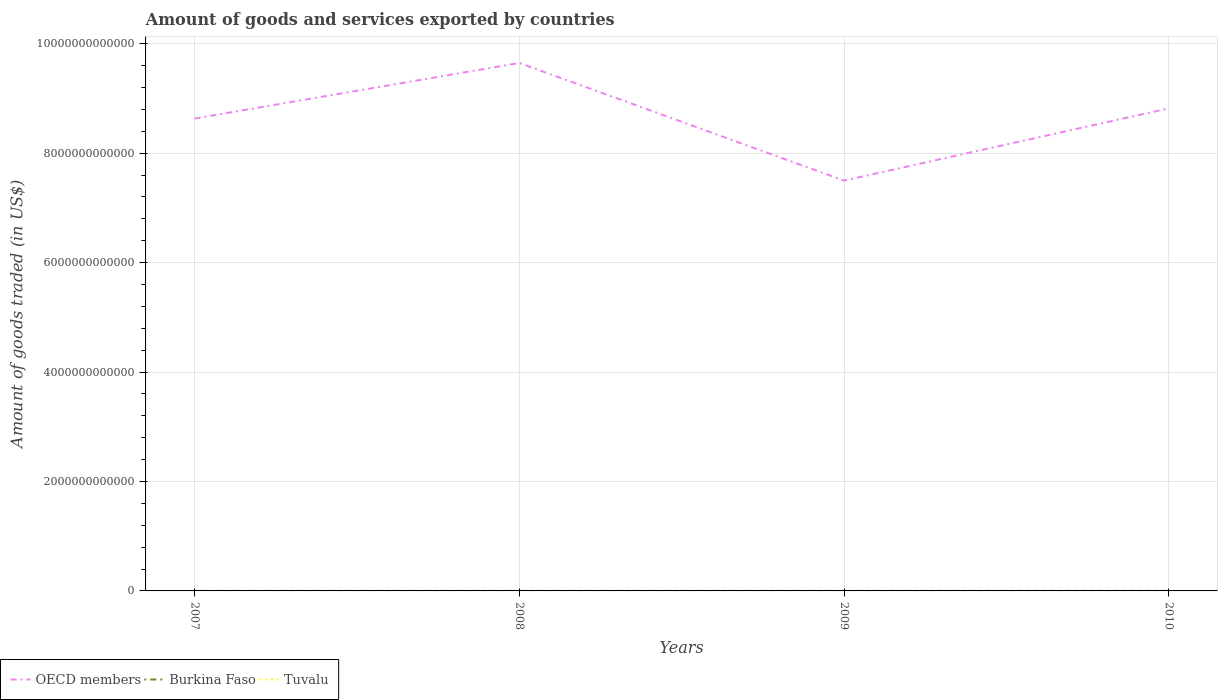How many different coloured lines are there?
Offer a terse response. 3. Does the line corresponding to Tuvalu intersect with the line corresponding to Burkina Faso?
Your answer should be very brief. No. Across all years, what is the maximum total amount of goods and services exported in OECD members?
Your response must be concise. 7.50e+12. What is the total total amount of goods and services exported in Tuvalu in the graph?
Keep it short and to the point. -7.44e+06. What is the difference between the highest and the second highest total amount of goods and services exported in Tuvalu?
Ensure brevity in your answer.  9.61e+06. What is the difference between the highest and the lowest total amount of goods and services exported in OECD members?
Offer a very short reply. 2. Is the total amount of goods and services exported in Tuvalu strictly greater than the total amount of goods and services exported in OECD members over the years?
Make the answer very short. Yes. How many years are there in the graph?
Offer a terse response. 4. What is the difference between two consecutive major ticks on the Y-axis?
Ensure brevity in your answer.  2.00e+12. Does the graph contain any zero values?
Offer a terse response. No. Does the graph contain grids?
Your answer should be compact. Yes. Where does the legend appear in the graph?
Provide a succinct answer. Bottom left. How many legend labels are there?
Keep it short and to the point. 3. What is the title of the graph?
Your answer should be compact. Amount of goods and services exported by countries. Does "Paraguay" appear as one of the legend labels in the graph?
Your answer should be compact. No. What is the label or title of the Y-axis?
Provide a short and direct response. Amount of goods traded (in US$). What is the Amount of goods traded (in US$) in OECD members in 2007?
Make the answer very short. 8.63e+12. What is the Amount of goods traded (in US$) of Burkina Faso in 2007?
Keep it short and to the point. 6.55e+08. What is the Amount of goods traded (in US$) in Tuvalu in 2007?
Offer a very short reply. 4.01e+05. What is the Amount of goods traded (in US$) in OECD members in 2008?
Give a very brief answer. 9.65e+12. What is the Amount of goods traded (in US$) in Burkina Faso in 2008?
Ensure brevity in your answer.  8.58e+08. What is the Amount of goods traded (in US$) of Tuvalu in 2008?
Make the answer very short. 5.43e+05. What is the Amount of goods traded (in US$) in OECD members in 2009?
Your answer should be very brief. 7.50e+12. What is the Amount of goods traded (in US$) of Burkina Faso in 2009?
Ensure brevity in your answer.  9.00e+08. What is the Amount of goods traded (in US$) of Tuvalu in 2009?
Keep it short and to the point. 2.57e+06. What is the Amount of goods traded (in US$) of OECD members in 2010?
Give a very brief answer. 8.82e+12. What is the Amount of goods traded (in US$) in Burkina Faso in 2010?
Give a very brief answer. 1.59e+09. What is the Amount of goods traded (in US$) of Tuvalu in 2010?
Your response must be concise. 1.00e+07. Across all years, what is the maximum Amount of goods traded (in US$) of OECD members?
Give a very brief answer. 9.65e+12. Across all years, what is the maximum Amount of goods traded (in US$) of Burkina Faso?
Make the answer very short. 1.59e+09. Across all years, what is the maximum Amount of goods traded (in US$) of Tuvalu?
Offer a terse response. 1.00e+07. Across all years, what is the minimum Amount of goods traded (in US$) in OECD members?
Offer a terse response. 7.50e+12. Across all years, what is the minimum Amount of goods traded (in US$) of Burkina Faso?
Make the answer very short. 6.55e+08. Across all years, what is the minimum Amount of goods traded (in US$) in Tuvalu?
Provide a short and direct response. 4.01e+05. What is the total Amount of goods traded (in US$) in OECD members in the graph?
Ensure brevity in your answer.  3.46e+13. What is the total Amount of goods traded (in US$) in Burkina Faso in the graph?
Your answer should be compact. 4.00e+09. What is the total Amount of goods traded (in US$) in Tuvalu in the graph?
Offer a terse response. 1.35e+07. What is the difference between the Amount of goods traded (in US$) in OECD members in 2007 and that in 2008?
Your answer should be very brief. -1.02e+12. What is the difference between the Amount of goods traded (in US$) of Burkina Faso in 2007 and that in 2008?
Make the answer very short. -2.03e+08. What is the difference between the Amount of goods traded (in US$) in Tuvalu in 2007 and that in 2008?
Provide a succinct answer. -1.42e+05. What is the difference between the Amount of goods traded (in US$) in OECD members in 2007 and that in 2009?
Offer a terse response. 1.13e+12. What is the difference between the Amount of goods traded (in US$) in Burkina Faso in 2007 and that in 2009?
Ensure brevity in your answer.  -2.45e+08. What is the difference between the Amount of goods traded (in US$) of Tuvalu in 2007 and that in 2009?
Ensure brevity in your answer.  -2.17e+06. What is the difference between the Amount of goods traded (in US$) of OECD members in 2007 and that in 2010?
Ensure brevity in your answer.  -1.86e+11. What is the difference between the Amount of goods traded (in US$) in Burkina Faso in 2007 and that in 2010?
Offer a very short reply. -9.36e+08. What is the difference between the Amount of goods traded (in US$) of Tuvalu in 2007 and that in 2010?
Provide a succinct answer. -9.61e+06. What is the difference between the Amount of goods traded (in US$) in OECD members in 2008 and that in 2009?
Offer a very short reply. 2.15e+12. What is the difference between the Amount of goods traded (in US$) in Burkina Faso in 2008 and that in 2009?
Your answer should be compact. -4.25e+07. What is the difference between the Amount of goods traded (in US$) in Tuvalu in 2008 and that in 2009?
Give a very brief answer. -2.03e+06. What is the difference between the Amount of goods traded (in US$) of OECD members in 2008 and that in 2010?
Keep it short and to the point. 8.30e+11. What is the difference between the Amount of goods traded (in US$) in Burkina Faso in 2008 and that in 2010?
Ensure brevity in your answer.  -7.33e+08. What is the difference between the Amount of goods traded (in US$) in Tuvalu in 2008 and that in 2010?
Your answer should be compact. -9.47e+06. What is the difference between the Amount of goods traded (in US$) of OECD members in 2009 and that in 2010?
Offer a terse response. -1.32e+12. What is the difference between the Amount of goods traded (in US$) in Burkina Faso in 2009 and that in 2010?
Offer a very short reply. -6.91e+08. What is the difference between the Amount of goods traded (in US$) in Tuvalu in 2009 and that in 2010?
Offer a terse response. -7.44e+06. What is the difference between the Amount of goods traded (in US$) in OECD members in 2007 and the Amount of goods traded (in US$) in Burkina Faso in 2008?
Your answer should be compact. 8.63e+12. What is the difference between the Amount of goods traded (in US$) in OECD members in 2007 and the Amount of goods traded (in US$) in Tuvalu in 2008?
Your answer should be very brief. 8.63e+12. What is the difference between the Amount of goods traded (in US$) of Burkina Faso in 2007 and the Amount of goods traded (in US$) of Tuvalu in 2008?
Offer a very short reply. 6.54e+08. What is the difference between the Amount of goods traded (in US$) of OECD members in 2007 and the Amount of goods traded (in US$) of Burkina Faso in 2009?
Give a very brief answer. 8.63e+12. What is the difference between the Amount of goods traded (in US$) in OECD members in 2007 and the Amount of goods traded (in US$) in Tuvalu in 2009?
Your answer should be very brief. 8.63e+12. What is the difference between the Amount of goods traded (in US$) of Burkina Faso in 2007 and the Amount of goods traded (in US$) of Tuvalu in 2009?
Your response must be concise. 6.52e+08. What is the difference between the Amount of goods traded (in US$) of OECD members in 2007 and the Amount of goods traded (in US$) of Burkina Faso in 2010?
Keep it short and to the point. 8.63e+12. What is the difference between the Amount of goods traded (in US$) of OECD members in 2007 and the Amount of goods traded (in US$) of Tuvalu in 2010?
Offer a terse response. 8.63e+12. What is the difference between the Amount of goods traded (in US$) of Burkina Faso in 2007 and the Amount of goods traded (in US$) of Tuvalu in 2010?
Make the answer very short. 6.45e+08. What is the difference between the Amount of goods traded (in US$) of OECD members in 2008 and the Amount of goods traded (in US$) of Burkina Faso in 2009?
Offer a very short reply. 9.65e+12. What is the difference between the Amount of goods traded (in US$) of OECD members in 2008 and the Amount of goods traded (in US$) of Tuvalu in 2009?
Offer a very short reply. 9.65e+12. What is the difference between the Amount of goods traded (in US$) of Burkina Faso in 2008 and the Amount of goods traded (in US$) of Tuvalu in 2009?
Make the answer very short. 8.55e+08. What is the difference between the Amount of goods traded (in US$) in OECD members in 2008 and the Amount of goods traded (in US$) in Burkina Faso in 2010?
Provide a short and direct response. 9.65e+12. What is the difference between the Amount of goods traded (in US$) of OECD members in 2008 and the Amount of goods traded (in US$) of Tuvalu in 2010?
Provide a short and direct response. 9.65e+12. What is the difference between the Amount of goods traded (in US$) in Burkina Faso in 2008 and the Amount of goods traded (in US$) in Tuvalu in 2010?
Provide a short and direct response. 8.48e+08. What is the difference between the Amount of goods traded (in US$) in OECD members in 2009 and the Amount of goods traded (in US$) in Burkina Faso in 2010?
Offer a terse response. 7.50e+12. What is the difference between the Amount of goods traded (in US$) in OECD members in 2009 and the Amount of goods traded (in US$) in Tuvalu in 2010?
Offer a terse response. 7.50e+12. What is the difference between the Amount of goods traded (in US$) of Burkina Faso in 2009 and the Amount of goods traded (in US$) of Tuvalu in 2010?
Keep it short and to the point. 8.90e+08. What is the average Amount of goods traded (in US$) in OECD members per year?
Your answer should be very brief. 8.65e+12. What is the average Amount of goods traded (in US$) of Burkina Faso per year?
Your answer should be compact. 1.00e+09. What is the average Amount of goods traded (in US$) in Tuvalu per year?
Your answer should be very brief. 3.38e+06. In the year 2007, what is the difference between the Amount of goods traded (in US$) in OECD members and Amount of goods traded (in US$) in Burkina Faso?
Provide a short and direct response. 8.63e+12. In the year 2007, what is the difference between the Amount of goods traded (in US$) of OECD members and Amount of goods traded (in US$) of Tuvalu?
Your answer should be very brief. 8.63e+12. In the year 2007, what is the difference between the Amount of goods traded (in US$) of Burkina Faso and Amount of goods traded (in US$) of Tuvalu?
Make the answer very short. 6.54e+08. In the year 2008, what is the difference between the Amount of goods traded (in US$) of OECD members and Amount of goods traded (in US$) of Burkina Faso?
Offer a very short reply. 9.65e+12. In the year 2008, what is the difference between the Amount of goods traded (in US$) in OECD members and Amount of goods traded (in US$) in Tuvalu?
Your answer should be very brief. 9.65e+12. In the year 2008, what is the difference between the Amount of goods traded (in US$) in Burkina Faso and Amount of goods traded (in US$) in Tuvalu?
Offer a terse response. 8.57e+08. In the year 2009, what is the difference between the Amount of goods traded (in US$) of OECD members and Amount of goods traded (in US$) of Burkina Faso?
Your response must be concise. 7.50e+12. In the year 2009, what is the difference between the Amount of goods traded (in US$) in OECD members and Amount of goods traded (in US$) in Tuvalu?
Offer a terse response. 7.50e+12. In the year 2009, what is the difference between the Amount of goods traded (in US$) in Burkina Faso and Amount of goods traded (in US$) in Tuvalu?
Your answer should be very brief. 8.98e+08. In the year 2010, what is the difference between the Amount of goods traded (in US$) of OECD members and Amount of goods traded (in US$) of Burkina Faso?
Give a very brief answer. 8.82e+12. In the year 2010, what is the difference between the Amount of goods traded (in US$) in OECD members and Amount of goods traded (in US$) in Tuvalu?
Your answer should be very brief. 8.82e+12. In the year 2010, what is the difference between the Amount of goods traded (in US$) in Burkina Faso and Amount of goods traded (in US$) in Tuvalu?
Give a very brief answer. 1.58e+09. What is the ratio of the Amount of goods traded (in US$) in OECD members in 2007 to that in 2008?
Your answer should be compact. 0.89. What is the ratio of the Amount of goods traded (in US$) in Burkina Faso in 2007 to that in 2008?
Your response must be concise. 0.76. What is the ratio of the Amount of goods traded (in US$) of Tuvalu in 2007 to that in 2008?
Your answer should be very brief. 0.74. What is the ratio of the Amount of goods traded (in US$) of OECD members in 2007 to that in 2009?
Your answer should be compact. 1.15. What is the ratio of the Amount of goods traded (in US$) of Burkina Faso in 2007 to that in 2009?
Your answer should be very brief. 0.73. What is the ratio of the Amount of goods traded (in US$) in Tuvalu in 2007 to that in 2009?
Offer a terse response. 0.16. What is the ratio of the Amount of goods traded (in US$) in OECD members in 2007 to that in 2010?
Your answer should be very brief. 0.98. What is the ratio of the Amount of goods traded (in US$) in Burkina Faso in 2007 to that in 2010?
Offer a terse response. 0.41. What is the ratio of the Amount of goods traded (in US$) in Tuvalu in 2007 to that in 2010?
Offer a terse response. 0.04. What is the ratio of the Amount of goods traded (in US$) in OECD members in 2008 to that in 2009?
Provide a short and direct response. 1.29. What is the ratio of the Amount of goods traded (in US$) in Burkina Faso in 2008 to that in 2009?
Provide a succinct answer. 0.95. What is the ratio of the Amount of goods traded (in US$) in Tuvalu in 2008 to that in 2009?
Give a very brief answer. 0.21. What is the ratio of the Amount of goods traded (in US$) of OECD members in 2008 to that in 2010?
Make the answer very short. 1.09. What is the ratio of the Amount of goods traded (in US$) of Burkina Faso in 2008 to that in 2010?
Give a very brief answer. 0.54. What is the ratio of the Amount of goods traded (in US$) in Tuvalu in 2008 to that in 2010?
Offer a very short reply. 0.05. What is the ratio of the Amount of goods traded (in US$) of OECD members in 2009 to that in 2010?
Offer a terse response. 0.85. What is the ratio of the Amount of goods traded (in US$) in Burkina Faso in 2009 to that in 2010?
Your answer should be compact. 0.57. What is the ratio of the Amount of goods traded (in US$) in Tuvalu in 2009 to that in 2010?
Keep it short and to the point. 0.26. What is the difference between the highest and the second highest Amount of goods traded (in US$) in OECD members?
Make the answer very short. 8.30e+11. What is the difference between the highest and the second highest Amount of goods traded (in US$) in Burkina Faso?
Your answer should be compact. 6.91e+08. What is the difference between the highest and the second highest Amount of goods traded (in US$) in Tuvalu?
Offer a very short reply. 7.44e+06. What is the difference between the highest and the lowest Amount of goods traded (in US$) in OECD members?
Offer a terse response. 2.15e+12. What is the difference between the highest and the lowest Amount of goods traded (in US$) of Burkina Faso?
Keep it short and to the point. 9.36e+08. What is the difference between the highest and the lowest Amount of goods traded (in US$) in Tuvalu?
Your answer should be compact. 9.61e+06. 